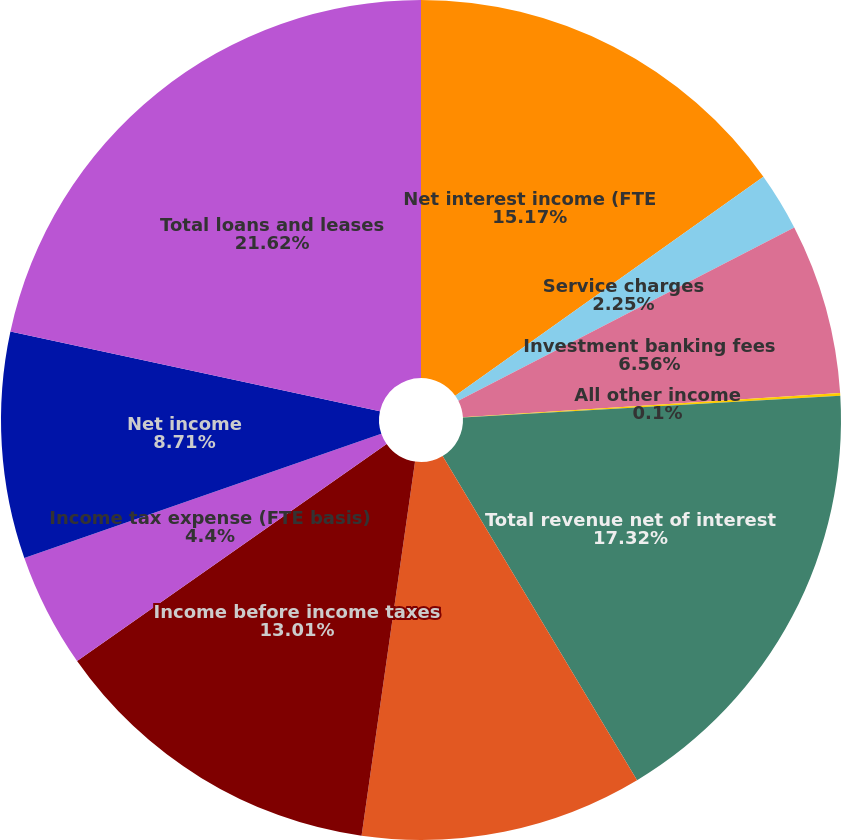Convert chart to OTSL. <chart><loc_0><loc_0><loc_500><loc_500><pie_chart><fcel>Net interest income (FTE<fcel>Service charges<fcel>Investment banking fees<fcel>All other income<fcel>Total revenue net of interest<fcel>Noninterest expense<fcel>Income before income taxes<fcel>Income tax expense (FTE basis)<fcel>Net income<fcel>Total loans and leases<nl><fcel>15.17%<fcel>2.25%<fcel>6.56%<fcel>0.1%<fcel>17.32%<fcel>10.86%<fcel>13.01%<fcel>4.4%<fcel>8.71%<fcel>21.62%<nl></chart> 